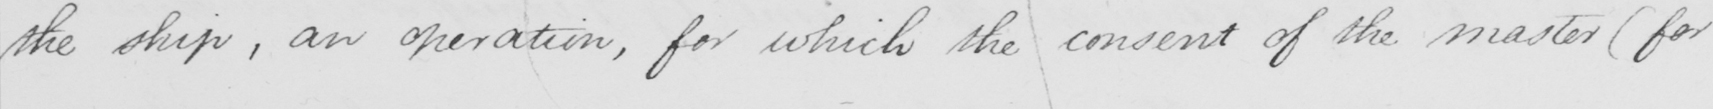What does this handwritten line say? the ship , an operation , for which the consent of the master  ( for 